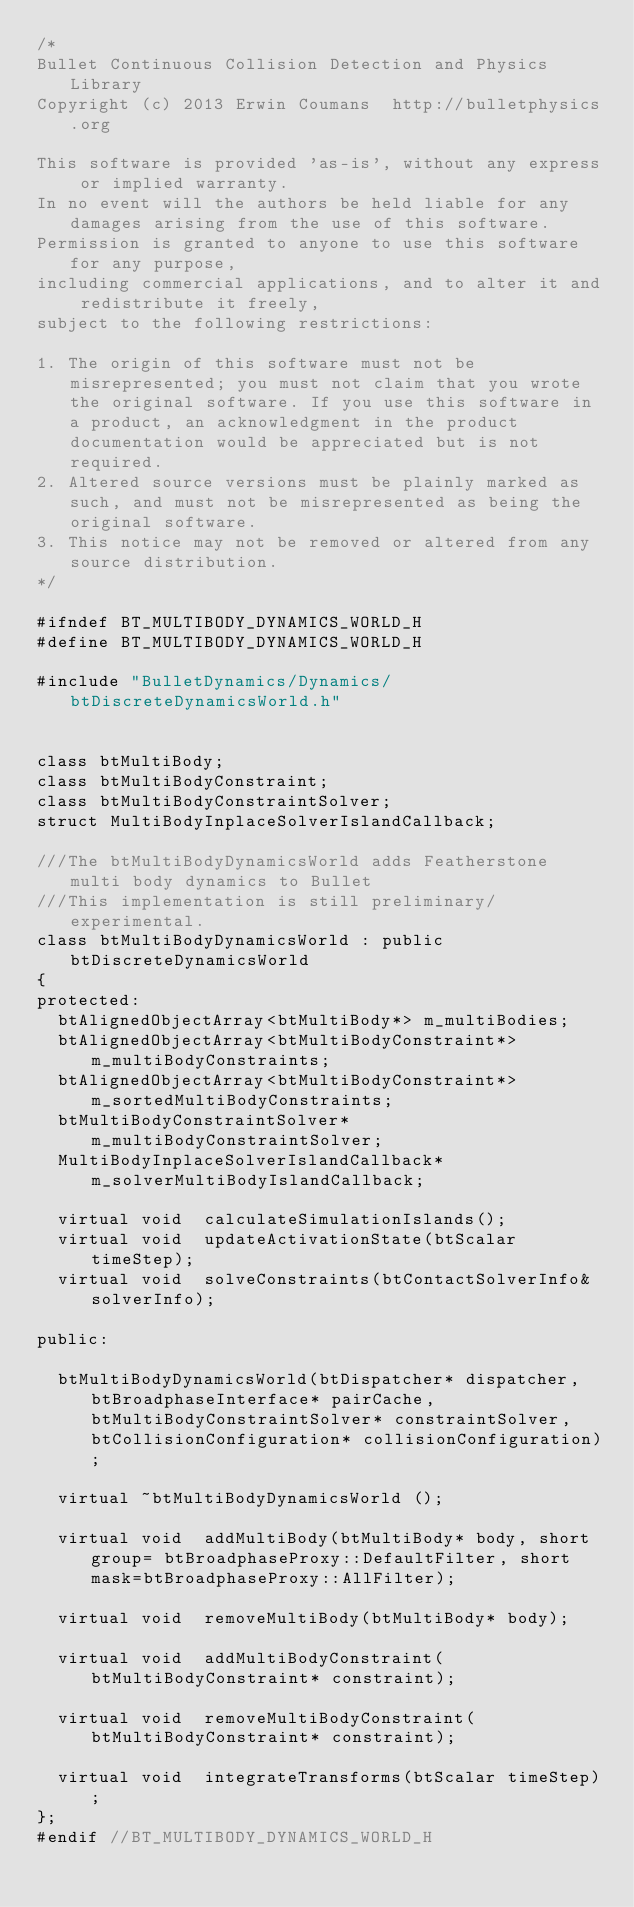<code> <loc_0><loc_0><loc_500><loc_500><_C_>/*
Bullet Continuous Collision Detection and Physics Library
Copyright (c) 2013 Erwin Coumans  http://bulletphysics.org

This software is provided 'as-is', without any express or implied warranty.
In no event will the authors be held liable for any damages arising from the use of this software.
Permission is granted to anyone to use this software for any purpose, 
including commercial applications, and to alter it and redistribute it freely, 
subject to the following restrictions:

1. The origin of this software must not be misrepresented; you must not claim that you wrote the original software. If you use this software in a product, an acknowledgment in the product documentation would be appreciated but is not required.
2. Altered source versions must be plainly marked as such, and must not be misrepresented as being the original software.
3. This notice may not be removed or altered from any source distribution.
*/

#ifndef BT_MULTIBODY_DYNAMICS_WORLD_H
#define BT_MULTIBODY_DYNAMICS_WORLD_H

#include "BulletDynamics/Dynamics/btDiscreteDynamicsWorld.h"


class btMultiBody;
class btMultiBodyConstraint;
class btMultiBodyConstraintSolver;
struct MultiBodyInplaceSolverIslandCallback;

///The btMultiBodyDynamicsWorld adds Featherstone multi body dynamics to Bullet
///This implementation is still preliminary/experimental.
class btMultiBodyDynamicsWorld : public btDiscreteDynamicsWorld
{
protected:
	btAlignedObjectArray<btMultiBody*> m_multiBodies;
	btAlignedObjectArray<btMultiBodyConstraint*> m_multiBodyConstraints;
	btAlignedObjectArray<btMultiBodyConstraint*> m_sortedMultiBodyConstraints;
	btMultiBodyConstraintSolver*	m_multiBodyConstraintSolver;
	MultiBodyInplaceSolverIslandCallback*	m_solverMultiBodyIslandCallback;

	virtual void	calculateSimulationIslands();
	virtual void	updateActivationState(btScalar timeStep);
	virtual void	solveConstraints(btContactSolverInfo& solverInfo);
	
public:

	btMultiBodyDynamicsWorld(btDispatcher* dispatcher,btBroadphaseInterface* pairCache,btMultiBodyConstraintSolver* constraintSolver,btCollisionConfiguration* collisionConfiguration);
	
	virtual ~btMultiBodyDynamicsWorld ();

	virtual void	addMultiBody(btMultiBody* body, short group= btBroadphaseProxy::DefaultFilter, short mask=btBroadphaseProxy::AllFilter);

	virtual void	removeMultiBody(btMultiBody* body);

	virtual void	addMultiBodyConstraint( btMultiBodyConstraint* constraint);

	virtual void	removeMultiBodyConstraint( btMultiBodyConstraint* constraint);

	virtual void	integrateTransforms(btScalar timeStep);
};
#endif //BT_MULTIBODY_DYNAMICS_WORLD_H
</code> 